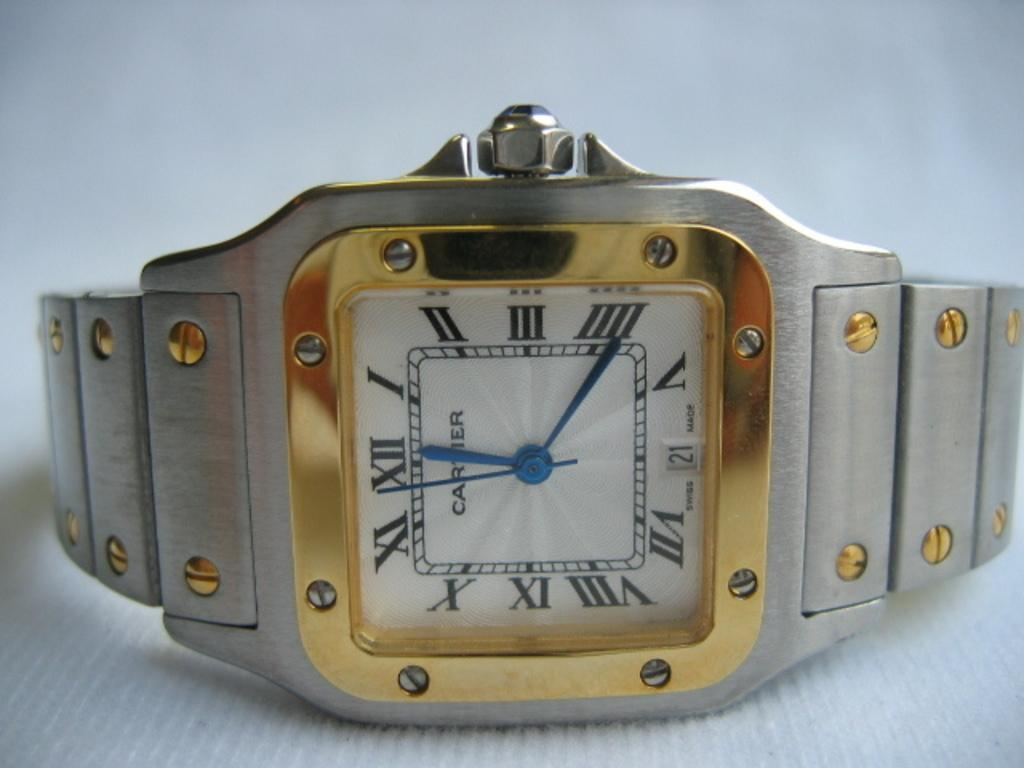<image>
Render a clear and concise summary of the photo. A gold cartier watch is on its side showing the time is approaching 12.22 